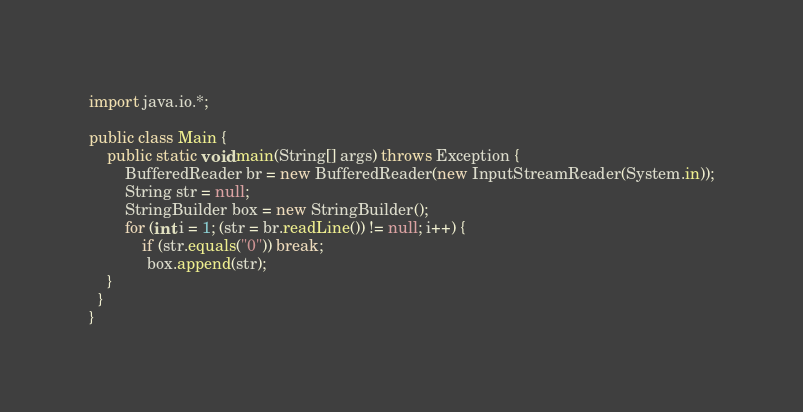<code> <loc_0><loc_0><loc_500><loc_500><_Java_>import java.io.*;
 
public class Main {
    public static void main(String[] args) throws Exception {
        BufferedReader br = new BufferedReader(new InputStreamReader(System.in));
        String str = null;
        StringBuilder box = new StringBuilder();
        for (int i = 1; (str = br.readLine()) != null; i++) {
            if (str.equals("0")) break;
             box.append(str);
    }
  }
}</code> 